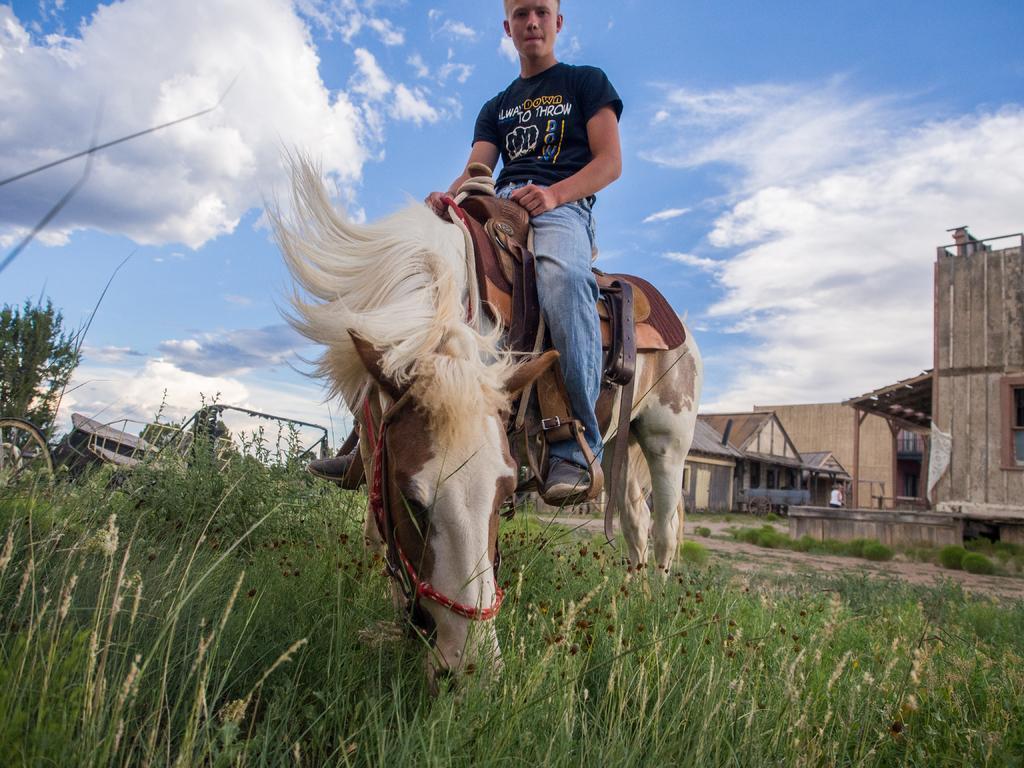How would you summarize this image in a sentence or two? A boy is standing on a white horse it's a grass at the down. There are houses in the right and a sky in the top. 